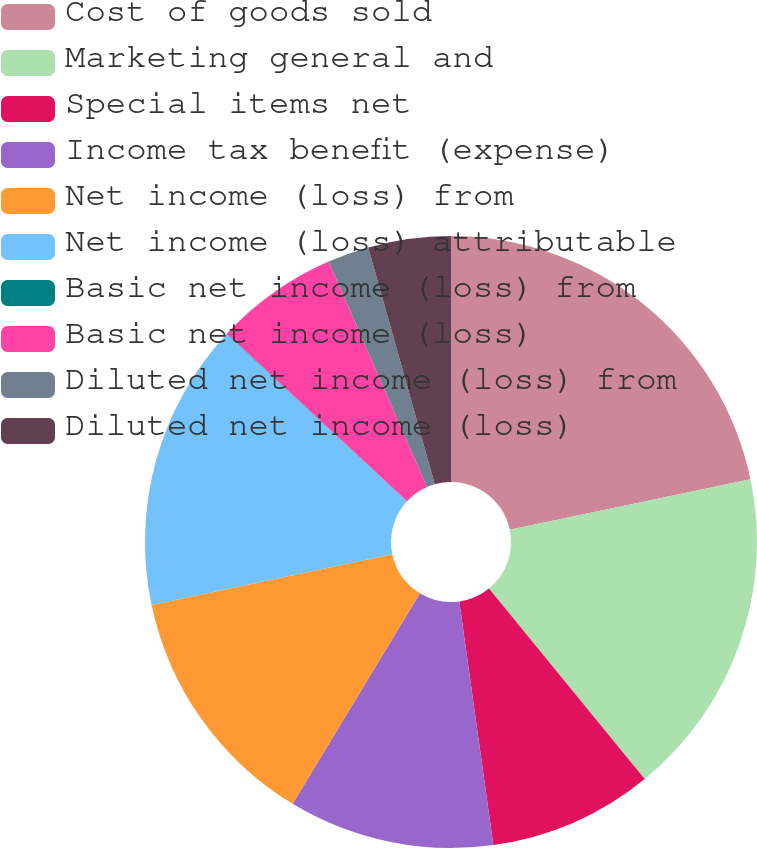Convert chart to OTSL. <chart><loc_0><loc_0><loc_500><loc_500><pie_chart><fcel>Cost of goods sold<fcel>Marketing general and<fcel>Special items net<fcel>Income tax benefit (expense)<fcel>Net income (loss) from<fcel>Net income (loss) attributable<fcel>Basic net income (loss) from<fcel>Basic net income (loss)<fcel>Diluted net income (loss) from<fcel>Diluted net income (loss)<nl><fcel>21.72%<fcel>17.38%<fcel>8.7%<fcel>10.87%<fcel>13.04%<fcel>15.21%<fcel>0.02%<fcel>6.53%<fcel>2.19%<fcel>4.36%<nl></chart> 